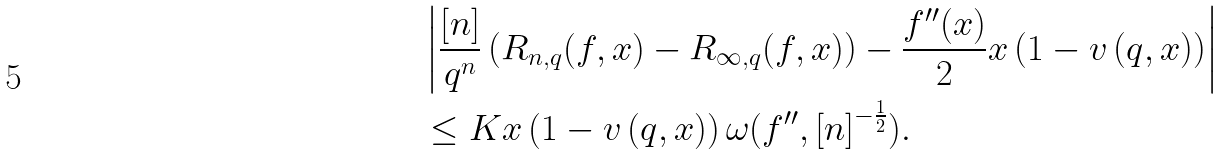Convert formula to latex. <formula><loc_0><loc_0><loc_500><loc_500>& \left | \frac { \left [ n \right ] } { q ^ { n } } \left ( R _ { n , q } ( f , x ) - R _ { \infty , q } ( f , x ) \right ) - \frac { f ^ { \prime \prime } ( x ) } { 2 } x \left ( 1 - v \left ( q , x \right ) \right ) \right | \\ & \leq K x \left ( 1 - v \left ( q , x \right ) \right ) \omega ( f ^ { \prime \prime } , \left [ n \right ] ^ { - \frac { 1 } { 2 } } ) .</formula> 